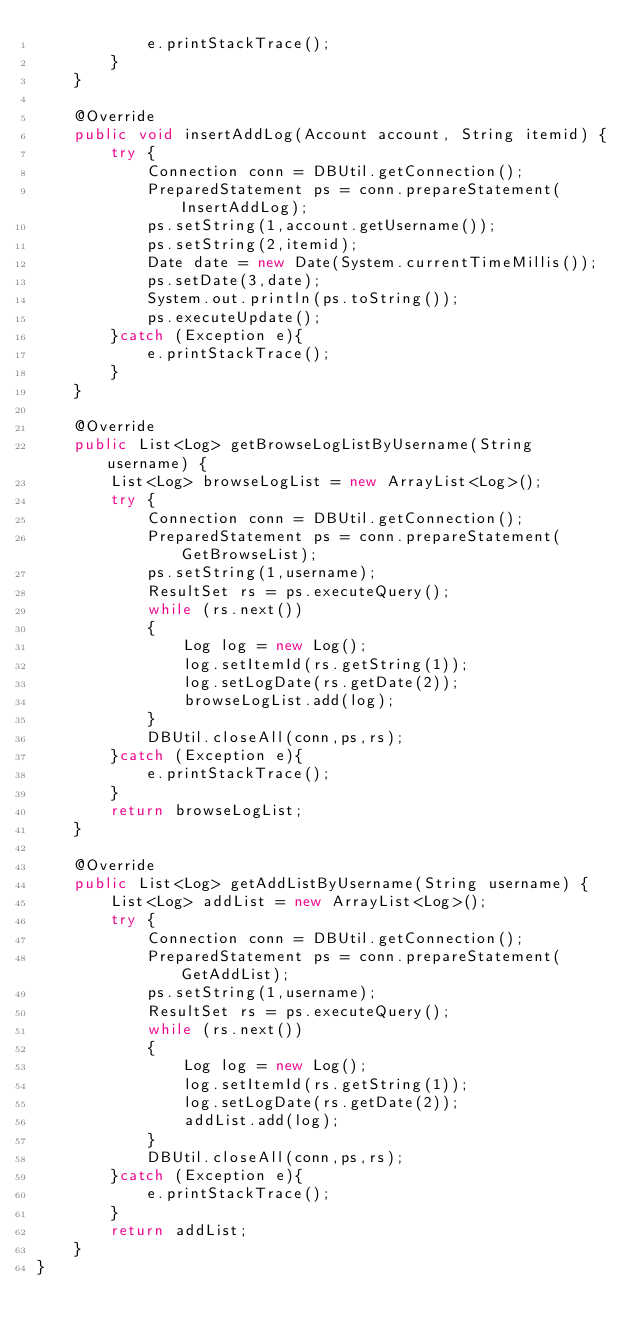Convert code to text. <code><loc_0><loc_0><loc_500><loc_500><_Java_>            e.printStackTrace();
        }
    }

    @Override
    public void insertAddLog(Account account, String itemid) {
        try {
            Connection conn = DBUtil.getConnection();
            PreparedStatement ps = conn.prepareStatement(InsertAddLog);
            ps.setString(1,account.getUsername());
            ps.setString(2,itemid);
            Date date = new Date(System.currentTimeMillis());
            ps.setDate(3,date);
            System.out.println(ps.toString());
            ps.executeUpdate();
        }catch (Exception e){
            e.printStackTrace();
        }
    }

    @Override
    public List<Log> getBrowseLogListByUsername(String username) {
        List<Log> browseLogList = new ArrayList<Log>();
        try {
            Connection conn = DBUtil.getConnection();
            PreparedStatement ps = conn.prepareStatement(GetBrowseList);
            ps.setString(1,username);
            ResultSet rs = ps.executeQuery();
            while (rs.next())
            {
                Log log = new Log();
                log.setItemId(rs.getString(1));
                log.setLogDate(rs.getDate(2));
                browseLogList.add(log);
            }
            DBUtil.closeAll(conn,ps,rs);
        }catch (Exception e){
            e.printStackTrace();
        }
        return browseLogList;
    }

    @Override
    public List<Log> getAddListByUsername(String username) {
        List<Log> addList = new ArrayList<Log>();
        try {
            Connection conn = DBUtil.getConnection();
            PreparedStatement ps = conn.prepareStatement(GetAddList);
            ps.setString(1,username);
            ResultSet rs = ps.executeQuery();
            while (rs.next())
            {
                Log log = new Log();
                log.setItemId(rs.getString(1));
                log.setLogDate(rs.getDate(2));
                addList.add(log);
            }
            DBUtil.closeAll(conn,ps,rs);
        }catch (Exception e){
            e.printStackTrace();
        }
        return addList;
    }
}
</code> 